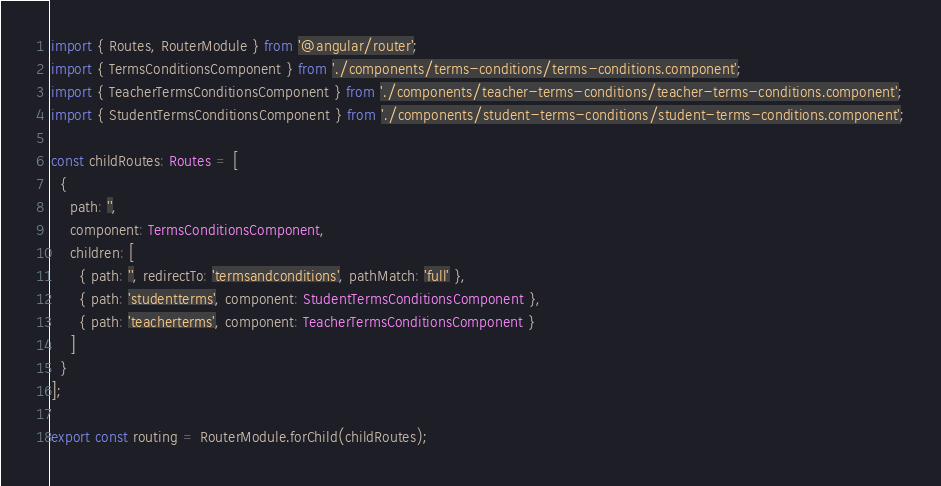<code> <loc_0><loc_0><loc_500><loc_500><_TypeScript_>import { Routes, RouterModule } from '@angular/router';
import { TermsConditionsComponent } from './components/terms-conditions/terms-conditions.component';
import { TeacherTermsConditionsComponent } from './components/teacher-terms-conditions/teacher-terms-conditions.component';
import { StudentTermsConditionsComponent } from './components/student-terms-conditions/student-terms-conditions.component';

const childRoutes: Routes = [
  {
    path: '',
    component: TermsConditionsComponent,
    children: [
      { path: '', redirectTo: 'termsandconditions', pathMatch: 'full' },
      { path: 'studentterms', component: StudentTermsConditionsComponent },
      { path: 'teacherterms', component: TeacherTermsConditionsComponent }
    ]
  }
];

export const routing = RouterModule.forChild(childRoutes);
</code> 